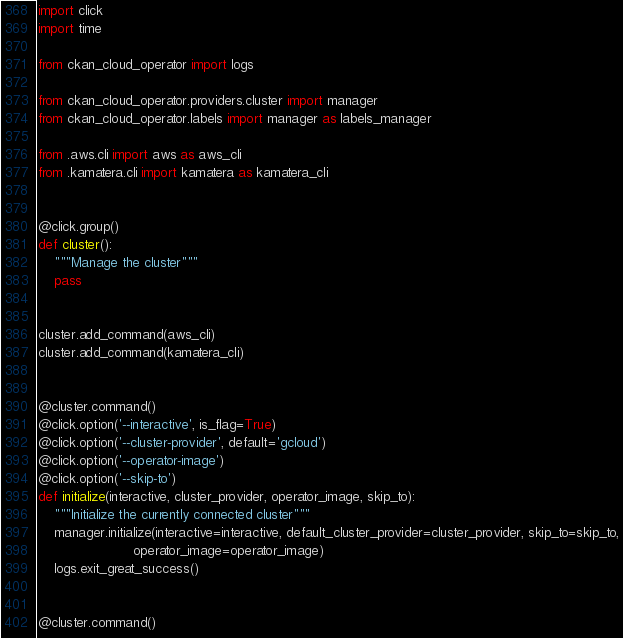Convert code to text. <code><loc_0><loc_0><loc_500><loc_500><_Python_>import click
import time

from ckan_cloud_operator import logs

from ckan_cloud_operator.providers.cluster import manager
from ckan_cloud_operator.labels import manager as labels_manager

from .aws.cli import aws as aws_cli
from .kamatera.cli import kamatera as kamatera_cli


@click.group()
def cluster():
    """Manage the cluster"""
    pass


cluster.add_command(aws_cli)
cluster.add_command(kamatera_cli)


@cluster.command()
@click.option('--interactive', is_flag=True)
@click.option('--cluster-provider', default='gcloud')
@click.option('--operator-image')
@click.option('--skip-to')
def initialize(interactive, cluster_provider, operator_image, skip_to):
    """Initialize the currently connected cluster"""
    manager.initialize(interactive=interactive, default_cluster_provider=cluster_provider, skip_to=skip_to,
                       operator_image=operator_image)
    logs.exit_great_success()


@cluster.command()</code> 